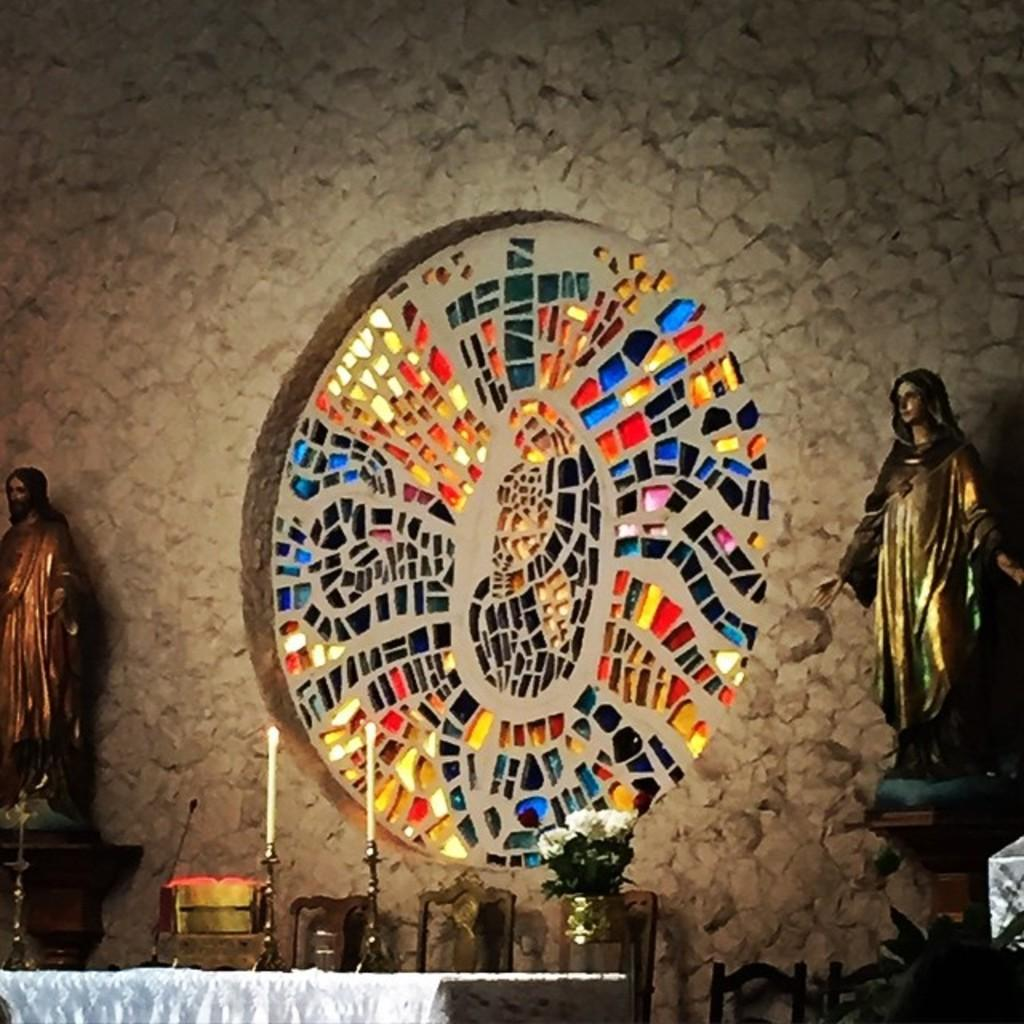What shape is the wall decor on the wall in the image? The wall decor is in the shape of a circle. What material is the wall decor made of? The wall decor is made of glass pieces. What can be seen in front of the wall decor? There are sculptures in front of the wall decor. What furniture is present in the image? There is a table and chairs in the image. What is the name of the person who created the heart-shaped sculpture in the image? There is no heart-shaped sculpture present in the image, and therefore no artist's name can be provided. 